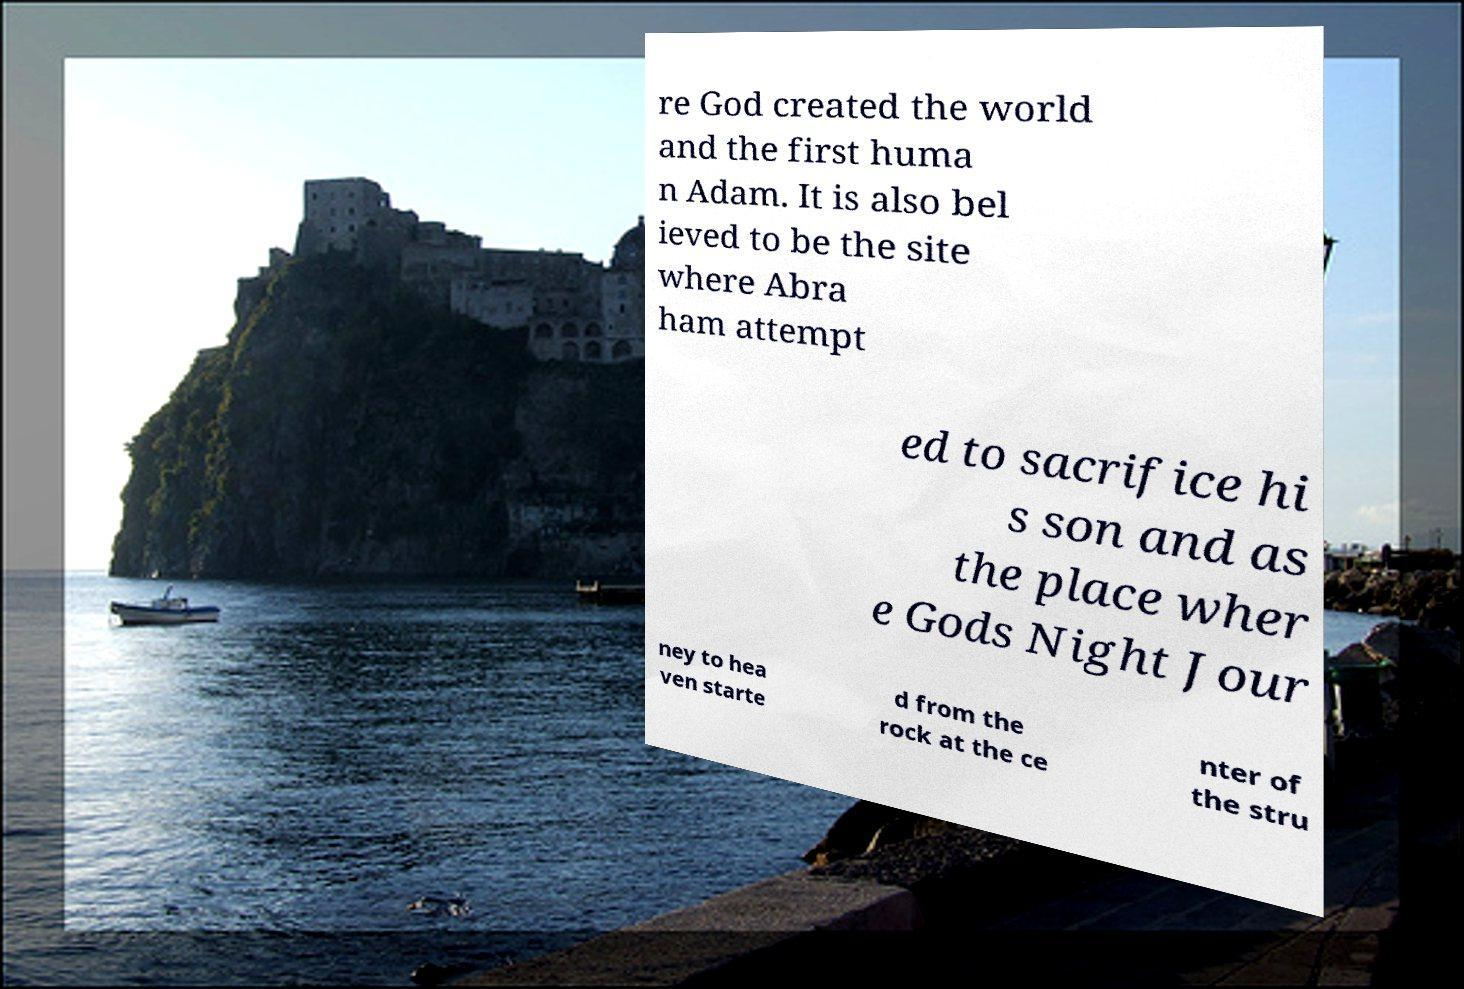Please read and relay the text visible in this image. What does it say? re God created the world and the first huma n Adam. It is also bel ieved to be the site where Abra ham attempt ed to sacrifice hi s son and as the place wher e Gods Night Jour ney to hea ven starte d from the rock at the ce nter of the stru 